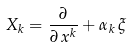Convert formula to latex. <formula><loc_0><loc_0><loc_500><loc_500>X _ { k } = \frac { \partial } { \partial \, x ^ { k } } + \alpha _ { k } \, \xi</formula> 